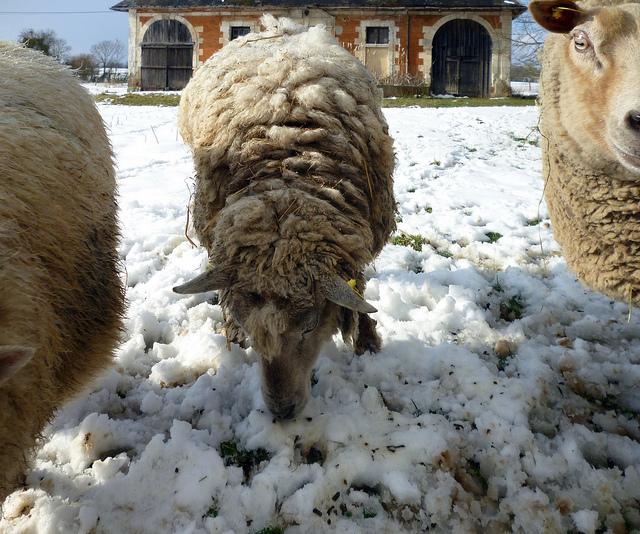How many eyes can be seen?
Quick response, please. 2. Where are iron gates?
Quick response, please. On building. Are the sheep eating the snow?
Give a very brief answer. Yes. 